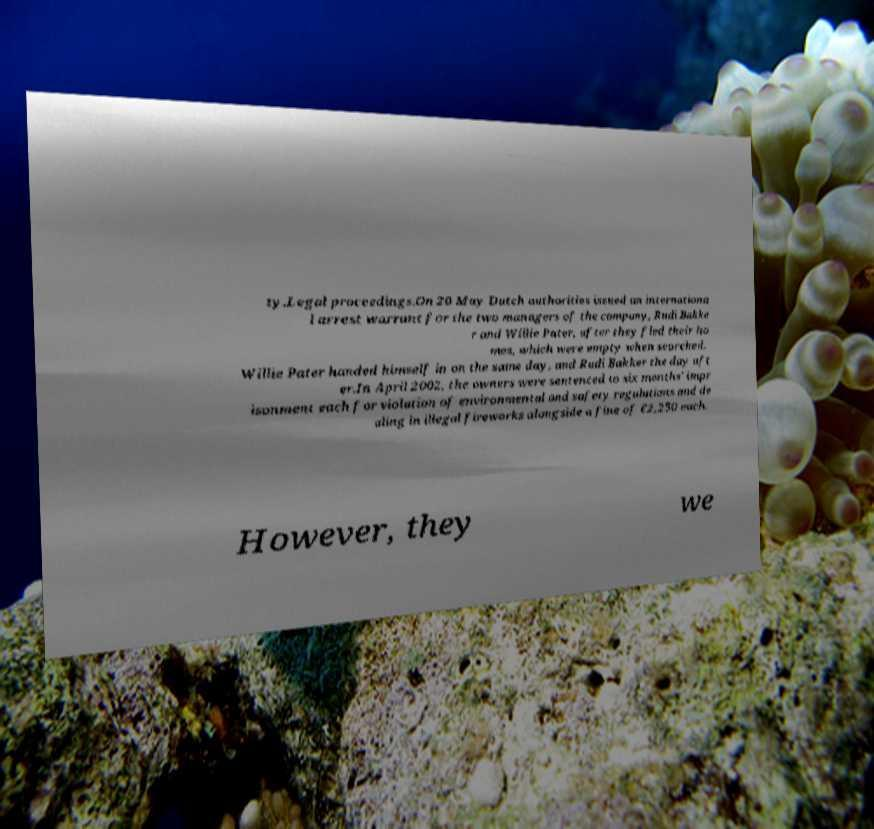Please read and relay the text visible in this image. What does it say? ty.Legal proceedings.On 20 May Dutch authorities issued an internationa l arrest warrant for the two managers of the company, Rudi Bakke r and Willie Pater, after they fled their ho mes, which were empty when searched. Willie Pater handed himself in on the same day, and Rudi Bakker the day aft er.In April 2002, the owners were sentenced to six months' impr isonment each for violation of environmental and safety regulations and de aling in illegal fireworks alongside a fine of €2,250 each. However, they we 